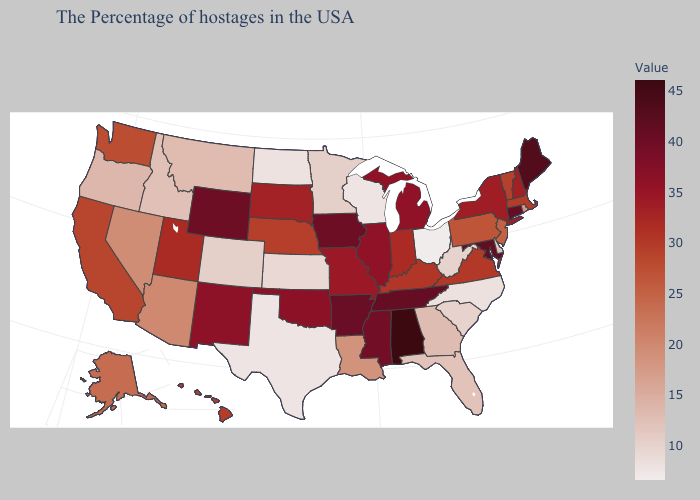Does North Dakota have a higher value than New Jersey?
Write a very short answer. No. Among the states that border Vermont , which have the lowest value?
Keep it brief. Massachusetts. Does Iowa have the highest value in the MidWest?
Be succinct. Yes. Among the states that border Oklahoma , does Texas have the lowest value?
Write a very short answer. Yes. Does Alabama have the highest value in the South?
Concise answer only. Yes. 